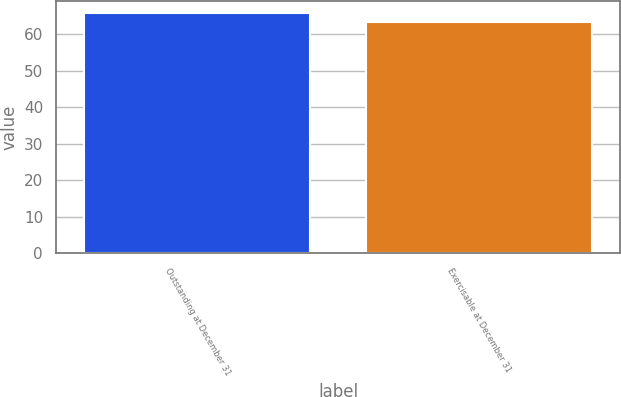<chart> <loc_0><loc_0><loc_500><loc_500><bar_chart><fcel>Outstanding at December 31<fcel>Exercisable at December 31<nl><fcel>65.96<fcel>63.39<nl></chart> 